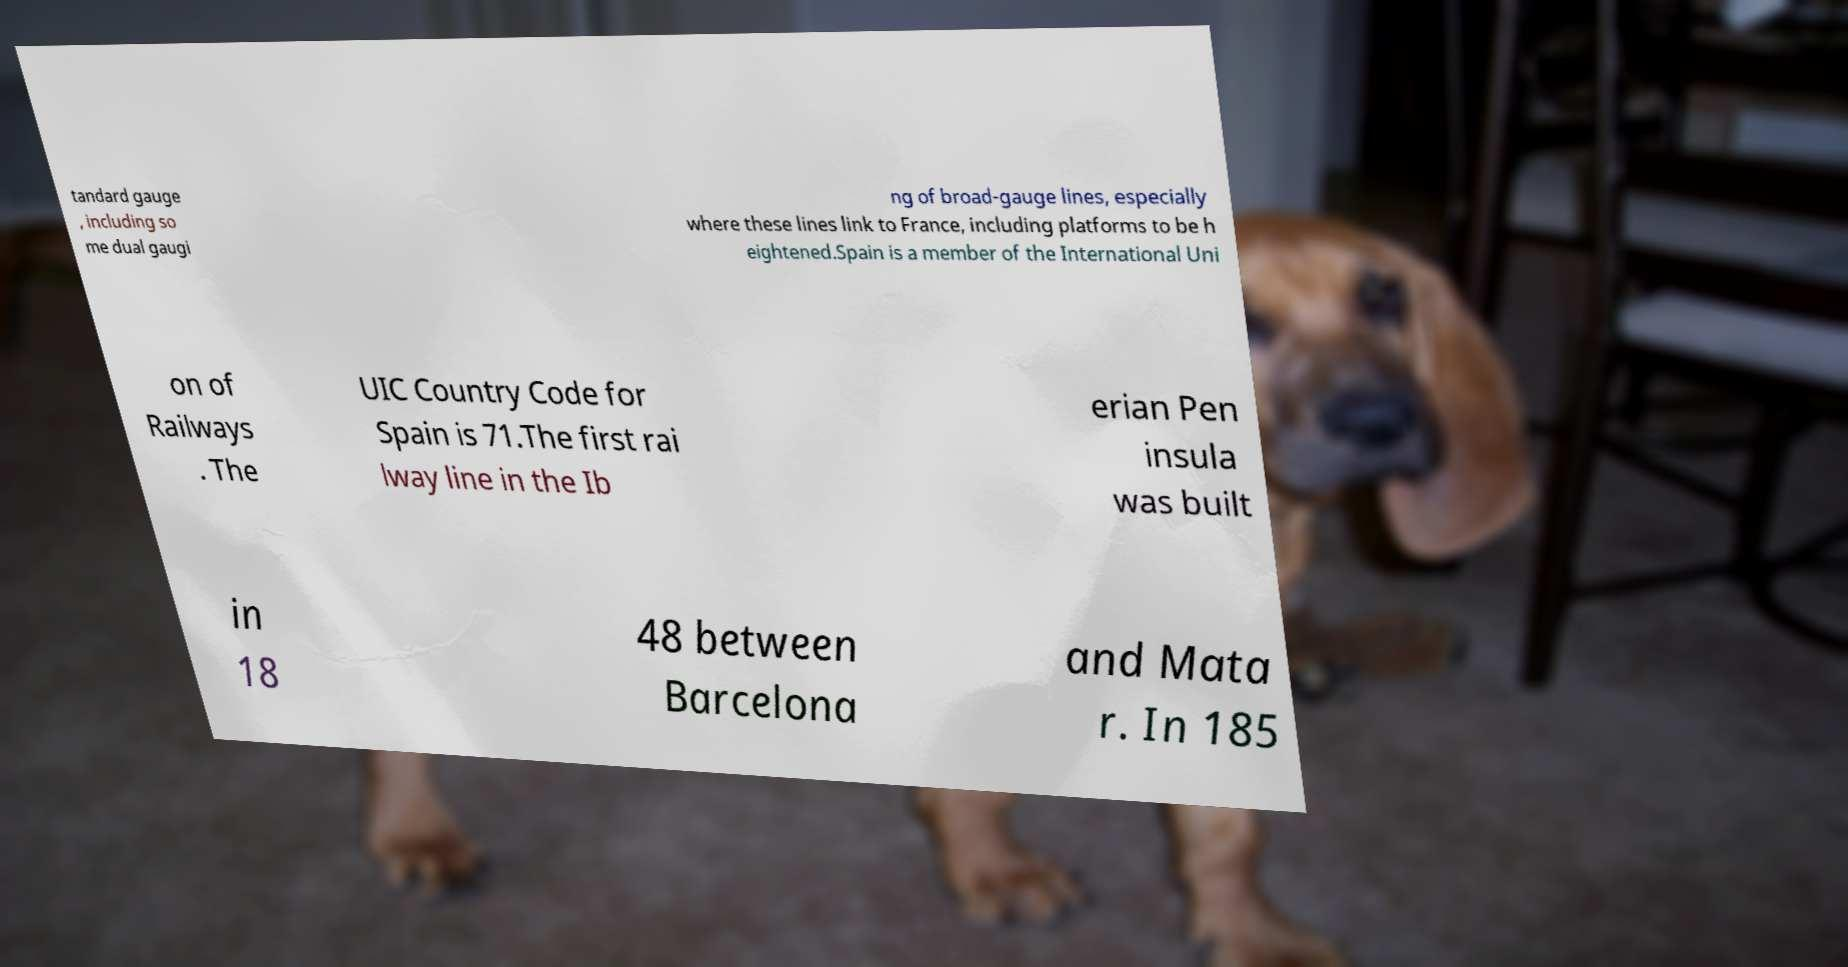Could you assist in decoding the text presented in this image and type it out clearly? tandard gauge , including so me dual gaugi ng of broad-gauge lines, especially where these lines link to France, including platforms to be h eightened.Spain is a member of the International Uni on of Railways . The UIC Country Code for Spain is 71.The first rai lway line in the Ib erian Pen insula was built in 18 48 between Barcelona and Mata r. In 185 